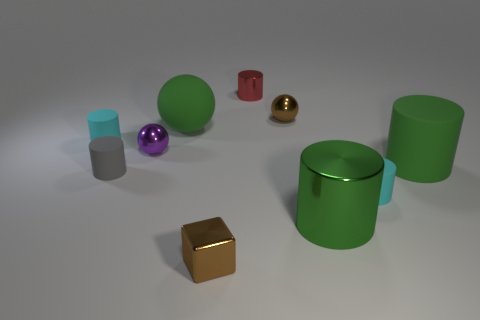Subtract all cyan cylinders. How many were subtracted if there are1cyan cylinders left? 1 Subtract all green cylinders. How many cylinders are left? 4 Subtract all small gray cylinders. How many cylinders are left? 5 Subtract 2 cylinders. How many cylinders are left? 4 Subtract all gray cylinders. Subtract all green cubes. How many cylinders are left? 5 Subtract all spheres. How many objects are left? 7 Subtract all small brown balls. Subtract all large green matte cylinders. How many objects are left? 8 Add 1 tiny red things. How many tiny red things are left? 2 Add 1 tiny gray cylinders. How many tiny gray cylinders exist? 2 Subtract 0 blue cubes. How many objects are left? 10 